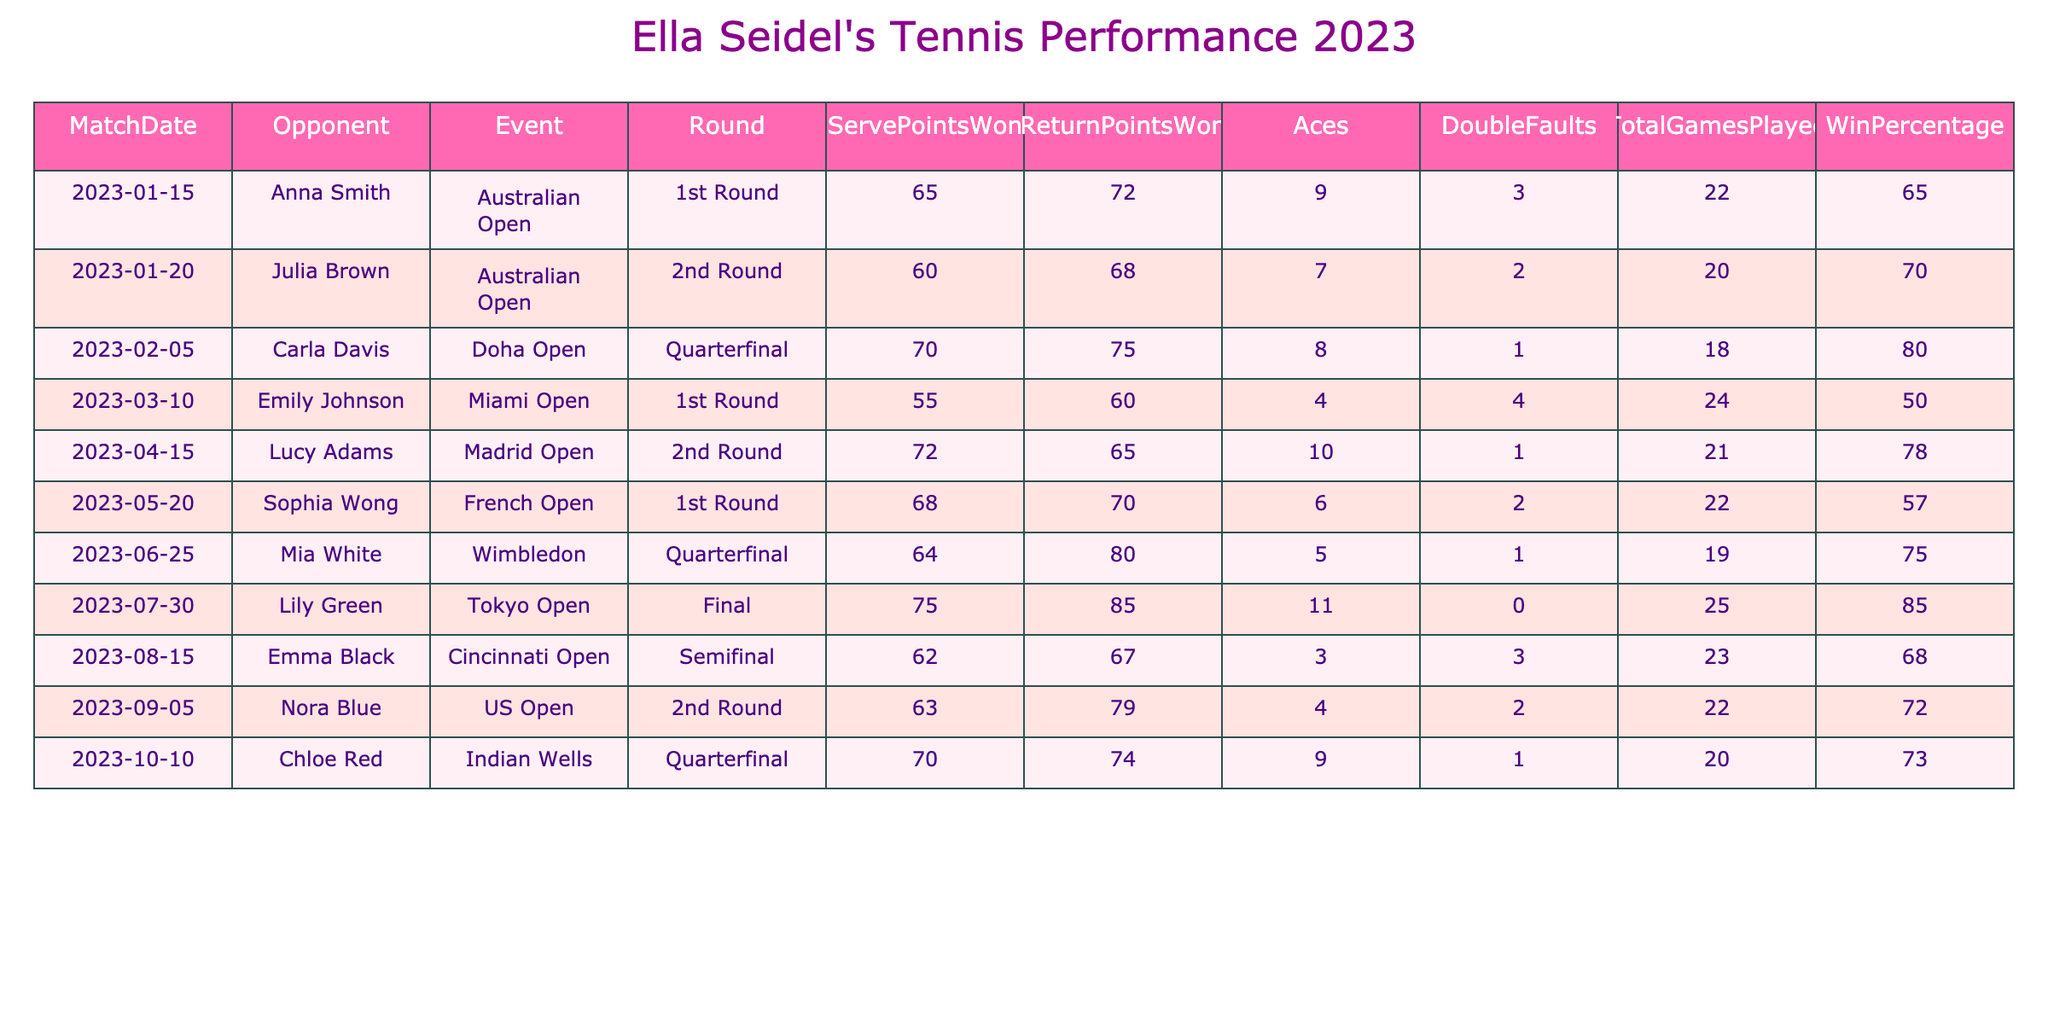What is Ella Seidel's highest win percentage in 2023? By scanning the "WinPercentage" column, the highest value is 85, which corresponds to her match against Lily Green in the Tokyo Open.
Answer: 85 How many aces did Ella Seidel hit in her match against Carla Davis? Referring to the "Aces" column for the match against Carla Davis, the value is 8.
Answer: 8 What was the total number of games played in Ella’s match at the French Open? Looking at the "TotalGamesPlayed" column for the French Open match shows a total of 22 games played.
Answer: 22 Which match had the lowest win percentage for Ella Seidel? By reviewing the "WinPercentage" column, the lowest value is 50, which was in her match against Emily Johnson in the Miami Open.
Answer: 50 In how many matches did Ella Seidel win more than 70% of her points on serve? Checking the "ServePointsWon," she won more than 70% in 4 matches (Doha Open, Madrid Open, Tokyo Open, and Indian Wells).
Answer: 4 What is Ella Seidel's average win percentage from the matches in Grand Slam events? The Grand Slam matches (Australian Open, French Open, Wimbledon, and US Open) have win percentages of 65, 57, 75, and 72, respectively. The average is (65 + 57 + 75 + 72) / 4 = 67.25.
Answer: 67.25 Did Ella Seidel win her quarterfinal matches? Evaluating the win percentages, she won her quarterfinal matches in the Doha Open (80%) and Wimbledon (75%), but not in the Miami Open (50%). Therefore, she won 2 of 3 quarterfinal matches.
Answer: No Which opponent did Ella Seidel have the highest return points won against? Looking through the "ReturnPointsWon" column, the highest value is 85 against Lily Green in the Tokyo Open.
Answer: Lily Green How many double faults did Ella commit in the Indian Wells quarterfinal? The "DoubleFaults" column shows that Ella committed 1 double fault during her match in Indian Wells.
Answer: 1 What is the difference between the total games played in the Australian Open and the Tokyo Open final? The total games in the Australian Open is 22 and in the Tokyo Open is 25. The difference is 25 - 22 = 3.
Answer: 3 